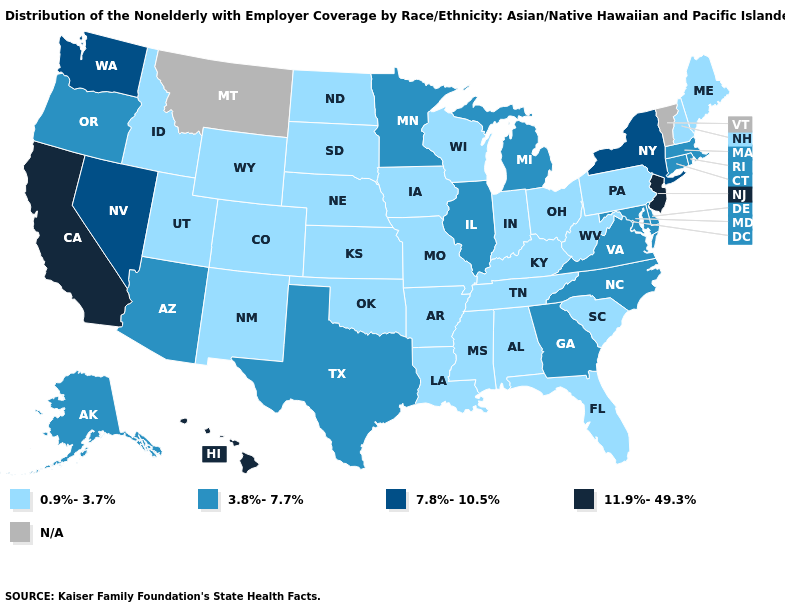Among the states that border Virginia , does West Virginia have the lowest value?
Write a very short answer. Yes. What is the value of Minnesota?
Answer briefly. 3.8%-7.7%. Does Hawaii have the highest value in the USA?
Keep it brief. Yes. Name the states that have a value in the range 7.8%-10.5%?
Write a very short answer. Nevada, New York, Washington. What is the value of Pennsylvania?
Answer briefly. 0.9%-3.7%. What is the lowest value in the USA?
Give a very brief answer. 0.9%-3.7%. Does the map have missing data?
Keep it brief. Yes. Name the states that have a value in the range 3.8%-7.7%?
Short answer required. Alaska, Arizona, Connecticut, Delaware, Georgia, Illinois, Maryland, Massachusetts, Michigan, Minnesota, North Carolina, Oregon, Rhode Island, Texas, Virginia. What is the value of Louisiana?
Be succinct. 0.9%-3.7%. Does New Jersey have the highest value in the Northeast?
Short answer required. Yes. Which states hav the highest value in the West?
Keep it brief. California, Hawaii. What is the highest value in the South ?
Be succinct. 3.8%-7.7%. Which states have the highest value in the USA?
Give a very brief answer. California, Hawaii, New Jersey. What is the value of Texas?
Answer briefly. 3.8%-7.7%. What is the value of Oklahoma?
Write a very short answer. 0.9%-3.7%. 